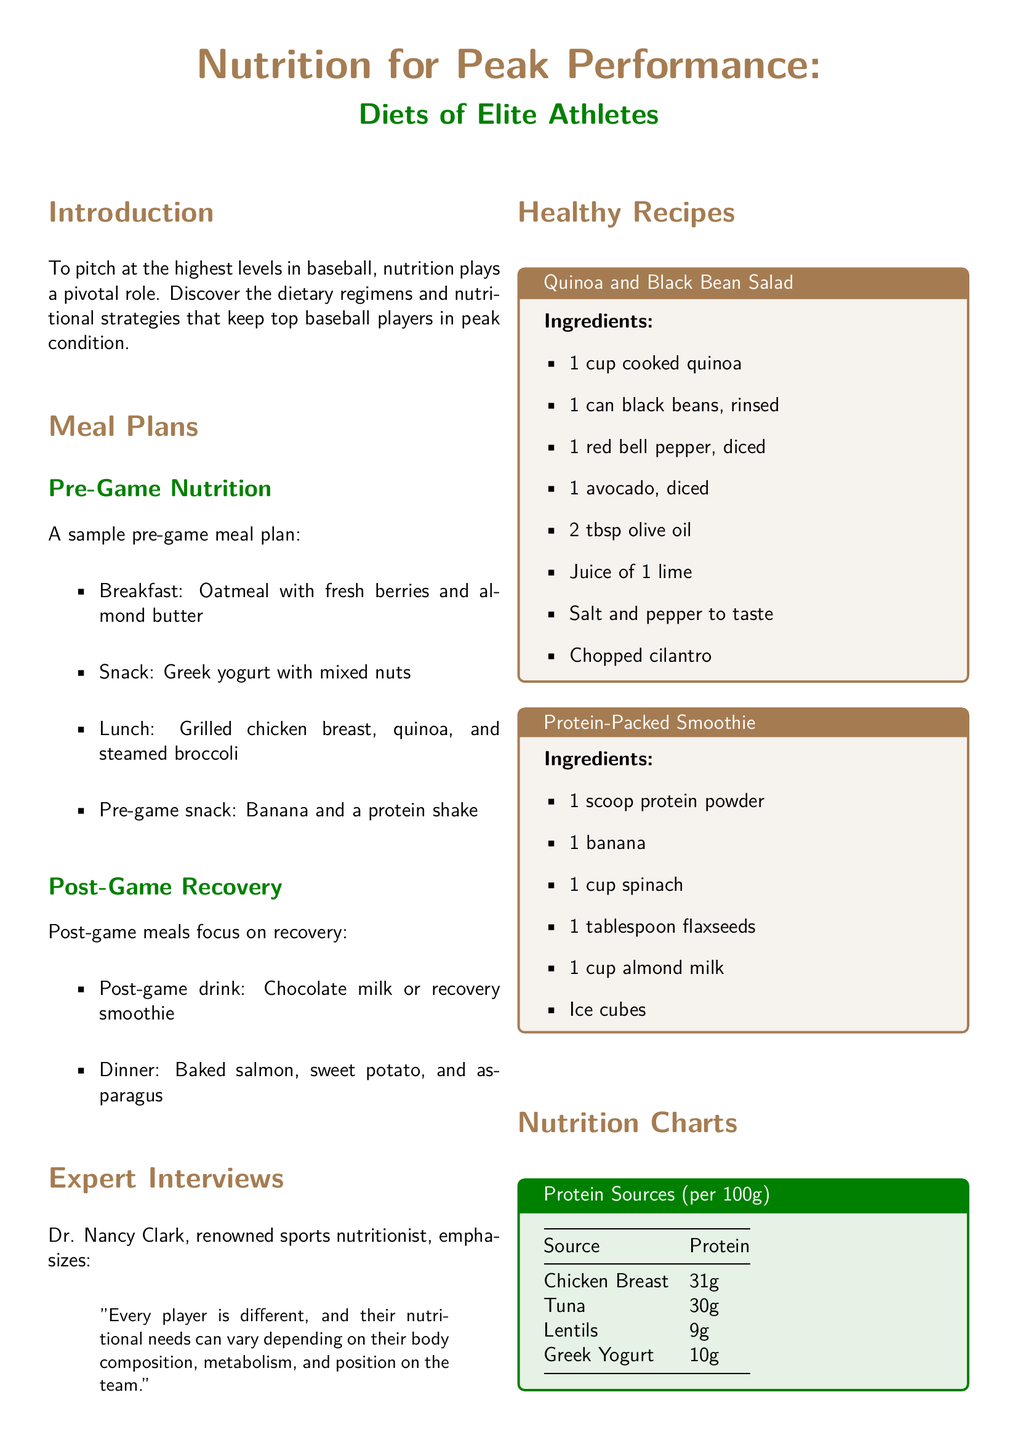What is the breakfast item in the pre-game meal plan? The document lists "Oatmeal with fresh berries and almond butter" as the breakfast item in the pre-game meal plan.
Answer: Oatmeal with fresh berries and almond butter Who is the renowned sports nutritionist mentioned? The document mentions Dr. Nancy Clark as the renowned sports nutritionist.
Answer: Dr. Nancy Clark What is one of the post-game meal items? The post-game meals include "Baked salmon, sweet potato, and asparagus."
Answer: Baked salmon, sweet potato, and asparagus How much protein does chicken breast provide per 100g? According to the nutrition chart in the document, chicken breast provides 31g of protein per 100g.
Answer: 31g Which recipe features almond milk as an ingredient? The document mentions "Protein-Packed Smoothie" as the recipe that features almond milk.
Answer: Protein-Packed Smoothie What is the primary focus of post-game meals? The document states that post-game meals focus on recovery.
Answer: Recovery How many grams of carbohydrates does oatmeal provide per 100g? The carbohydrates section shows that oatmeal provides 12g of carbohydrates per 100g.
Answer: 12g What color theme is used for section headers? The section headers use a theme based on baseball brown.
Answer: Baseball brown 